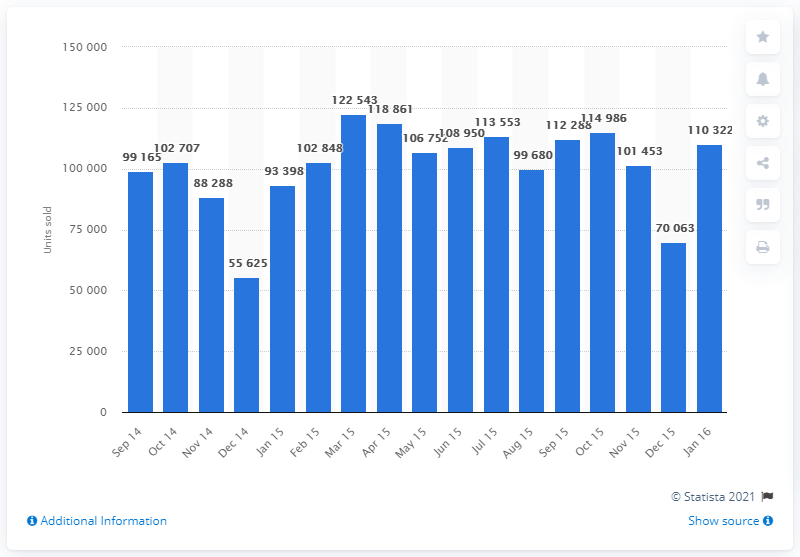Outline some significant characteristics in this image. The number of cars auctioned in December 2014 was 55,625. 